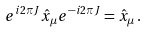<formula> <loc_0><loc_0><loc_500><loc_500>e ^ { i 2 \pi J } \hat { x } _ { \mu } e ^ { - i 2 \pi J } = \hat { x } _ { \mu } \, .</formula> 